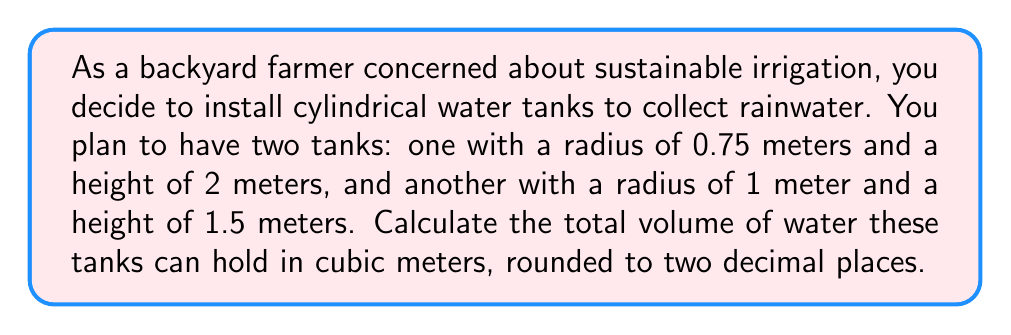What is the answer to this math problem? Let's approach this problem step-by-step:

1. Recall the formula for the volume of a cylinder:
   $$V = \pi r^2 h$$
   where $V$ is volume, $r$ is radius, and $h$ is height.

2. For the first tank:
   - Radius $(r_1) = 0.75$ m
   - Height $(h_1) = 2$ m
   
   Volume of first tank:
   $$V_1 = \pi (0.75\text{ m})^2 (2\text{ m}) = 3.53\text{ m}^3$$

3. For the second tank:
   - Radius $(r_2) = 1$ m
   - Height $(h_2) = 1.5$ m
   
   Volume of second tank:
   $$V_2 = \pi (1\text{ m})^2 (1.5\text{ m}) = 4.71\text{ m}^3$$

4. Total volume:
   $$V_{total} = V_1 + V_2 = 3.53\text{ m}^3 + 4.71\text{ m}^3 = 8.24\text{ m}^3$$

5. Rounding to two decimal places: 8.24 m³
Answer: 8.24 m³ 